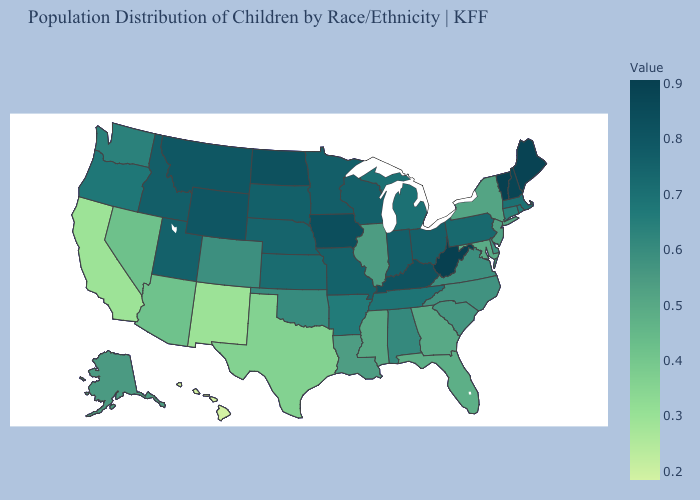Does Tennessee have a higher value than West Virginia?
Give a very brief answer. No. Does Tennessee have the lowest value in the USA?
Keep it brief. No. Does Wyoming have the highest value in the West?
Quick response, please. Yes. Does West Virginia have the highest value in the USA?
Write a very short answer. Yes. Is the legend a continuous bar?
Write a very short answer. Yes. Which states have the lowest value in the MidWest?
Short answer required. Illinois. Does Wyoming have the highest value in the West?
Quick response, please. Yes. Which states have the lowest value in the South?
Give a very brief answer. Texas. 